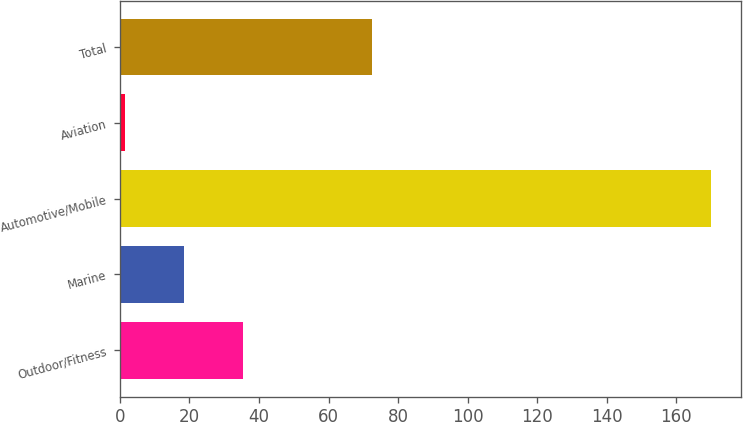Convert chart. <chart><loc_0><loc_0><loc_500><loc_500><bar_chart><fcel>Outdoor/Fitness<fcel>Marine<fcel>Automotive/Mobile<fcel>Aviation<fcel>Total<nl><fcel>35.28<fcel>18.44<fcel>170<fcel>1.6<fcel>72.6<nl></chart> 